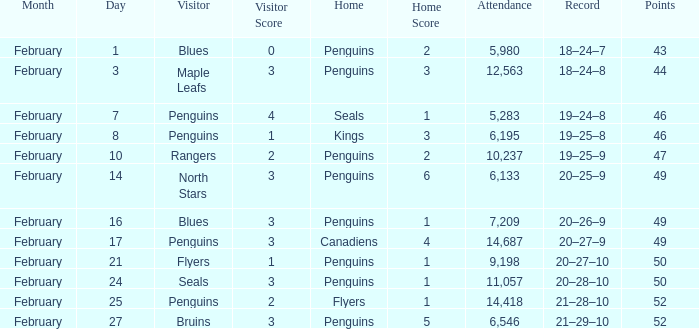Home of kings had what score? 1–3. 